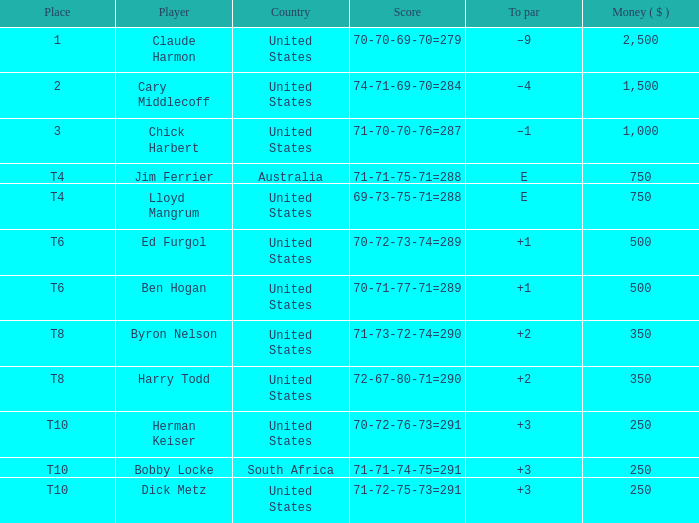What is the to par for the player from the United States with a 72-67-80-71=290 score? 2.0. 